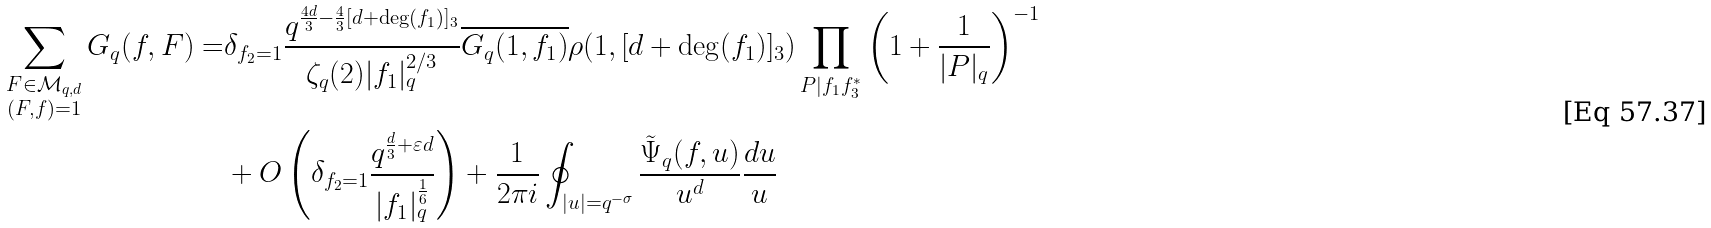Convert formula to latex. <formula><loc_0><loc_0><loc_500><loc_500>\sum _ { \substack { F \in \mathcal { M } _ { q , d } \\ ( F , f ) = 1 } } G _ { q } ( f , F ) = & \delta _ { f _ { 2 } = 1 } \frac { q ^ { \frac { 4 d } { 3 } - \frac { 4 } { 3 } [ d + \deg ( f _ { 1 } ) ] _ { 3 } } } { \zeta _ { q } ( 2 ) | f _ { 1 } | _ { q } ^ { 2 / 3 } } \overline { G _ { q } ( 1 , f _ { 1 } ) } \rho ( 1 , [ d + \deg ( f _ { 1 } ) ] _ { 3 } ) \prod _ { P | f _ { 1 } f _ { 3 } ^ { * } } \left ( 1 + \frac { 1 } { | P | _ { q } } \right ) ^ { - 1 } \\ & + O \left ( \delta _ { f _ { 2 } = 1 } \frac { q ^ { \frac { d } { 3 } + \varepsilon d } } { | f _ { 1 } | _ { q } ^ { \frac { 1 } { 6 } } } \right ) + \frac { 1 } { 2 \pi i } \oint _ { | u | = q ^ { - \sigma } } \frac { \tilde { \Psi } _ { q } ( f , u ) } { u ^ { d } } \frac { d u } { u }</formula> 